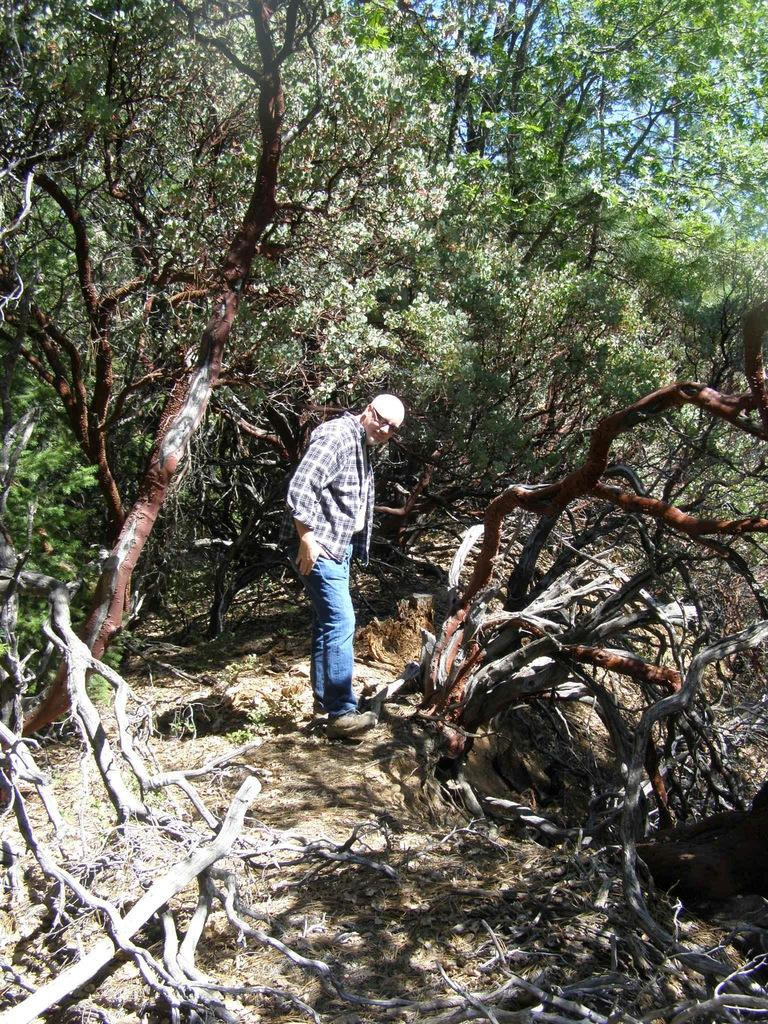Who is present in the image? There is a man in the image. What is the man wearing on his face? The man is wearing glasses (specs) in the image. What type of natural environment is visible in the image? There are many trees in the image, indicating a forest or wooded area. What can be seen in the background of the image? The sky is visible in the background of the image. How many toes are visible on the man's feet in the image? There is no indication of the man's feet or toes in the image, so it cannot be determined. 